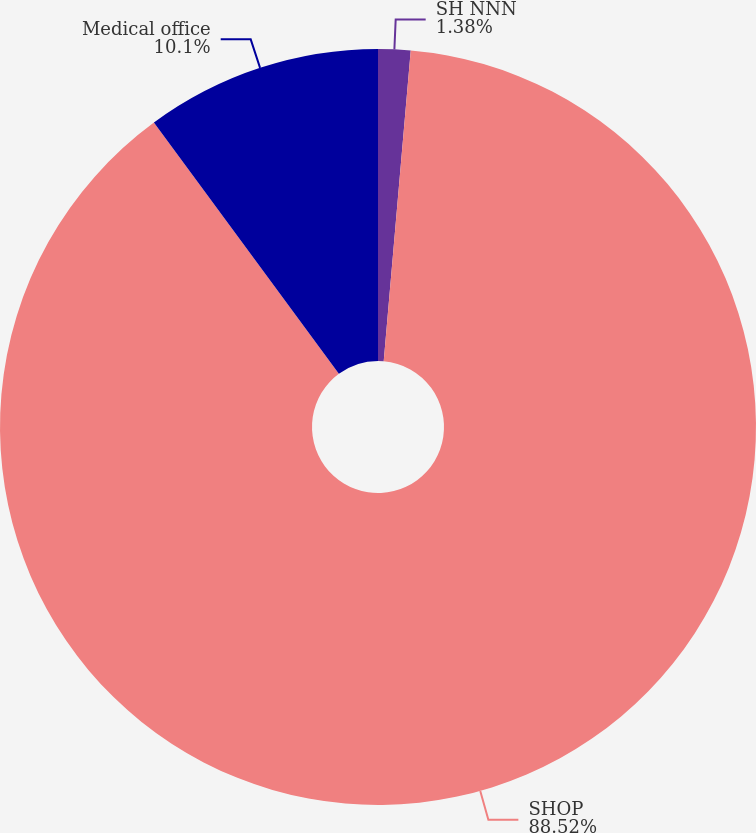<chart> <loc_0><loc_0><loc_500><loc_500><pie_chart><fcel>SH NNN<fcel>SHOP<fcel>Medical office<nl><fcel>1.38%<fcel>88.52%<fcel>10.1%<nl></chart> 